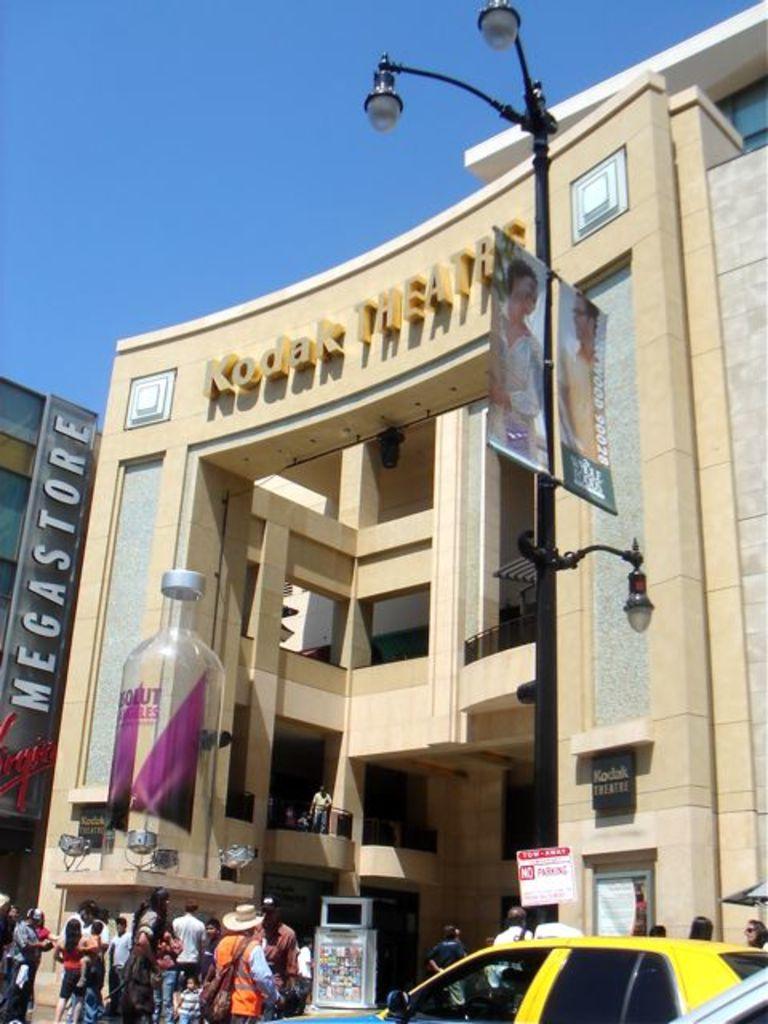What is the name of this building?
Your response must be concise. Kodak theatre. 